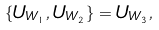Convert formula to latex. <formula><loc_0><loc_0><loc_500><loc_500>\{ U _ { W _ { 1 } } , U _ { W _ { 2 } } \} = U _ { W _ { 3 } } ,</formula> 